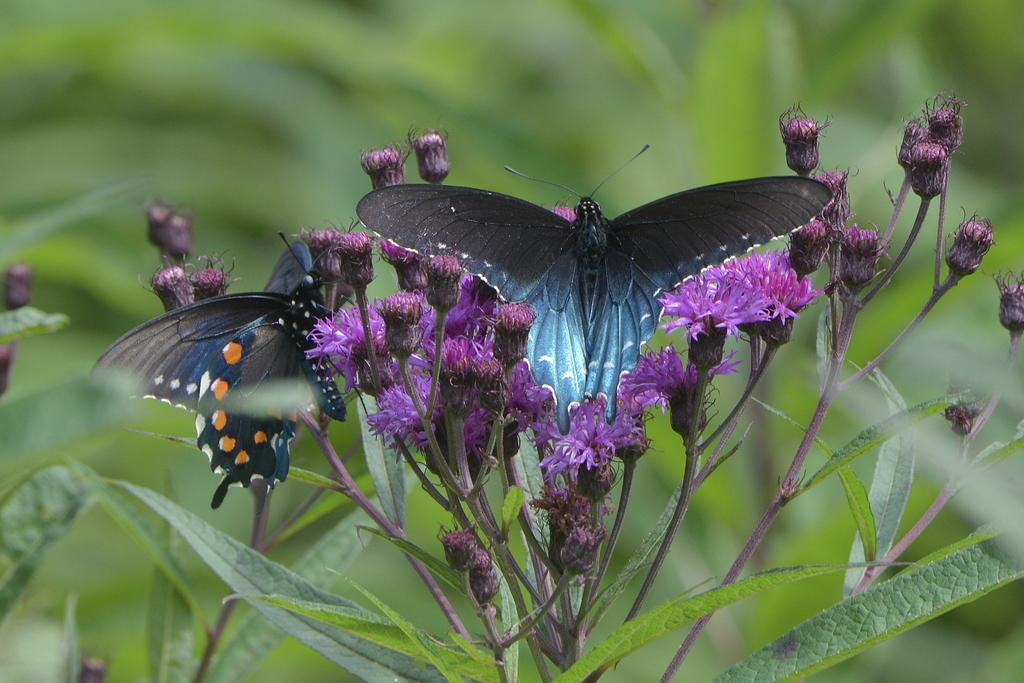What is the main subject in the middle of the image? There are flowers in the middle of the image. Are there any animals present on the flowers? Yes, two butterflies are present on the flowers. What can be seen at the bottom of the image? There are plants at the bottom of the image. How would you describe the background of the image? The background of the image is blurred. What type of harbor can be seen in the background of the image? There is no harbor present in the image; the background is blurred. How is the distribution of flowers and plants managed in the image? The image does not depict any management or distribution of flowers and plants; it simply shows them in their natural state. 